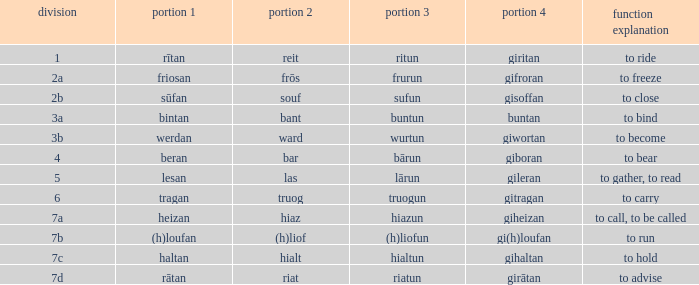What is the part 4 when part 1 is "lesan"? Gileran. 